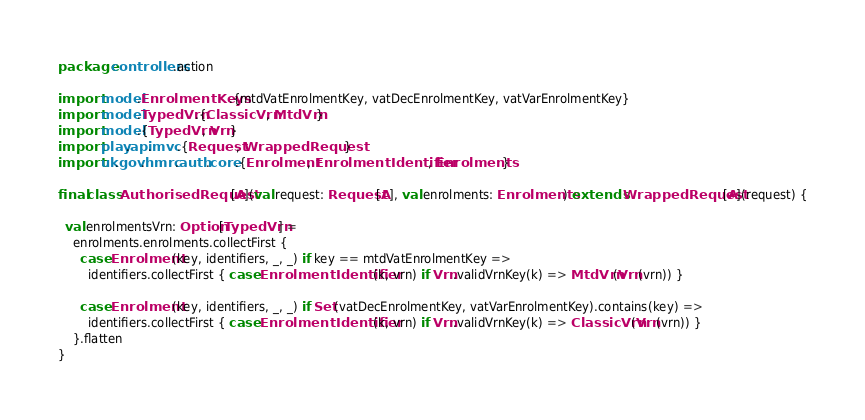<code> <loc_0><loc_0><loc_500><loc_500><_Scala_>
package controllers.action

import model.EnrolmentKeys.{mtdVatEnrolmentKey, vatDecEnrolmentKey, vatVarEnrolmentKey}
import model.TypedVrn.{ClassicVrn, MtdVrn}
import model.{TypedVrn, Vrn}
import play.api.mvc.{Request, WrappedRequest}
import uk.gov.hmrc.auth.core.{Enrolment, EnrolmentIdentifier, Enrolments}

final class AuthorisedRequest[A](val request: Request[A], val enrolments: Enrolments) extends WrappedRequest[A](request) {

  val enrolmentsVrn: Option[TypedVrn] =
    enrolments.enrolments.collectFirst {
      case Enrolment(key, identifiers, _, _) if key == mtdVatEnrolmentKey =>
        identifiers.collectFirst { case EnrolmentIdentifier(k, vrn) if Vrn.validVrnKey(k) => MtdVrn(Vrn(vrn)) }

      case Enrolment(key, identifiers, _, _) if Set(vatDecEnrolmentKey, vatVarEnrolmentKey).contains(key) =>
        identifiers.collectFirst { case EnrolmentIdentifier(k, vrn) if Vrn.validVrnKey(k) => ClassicVrn(Vrn(vrn)) }
    }.flatten
}
</code> 